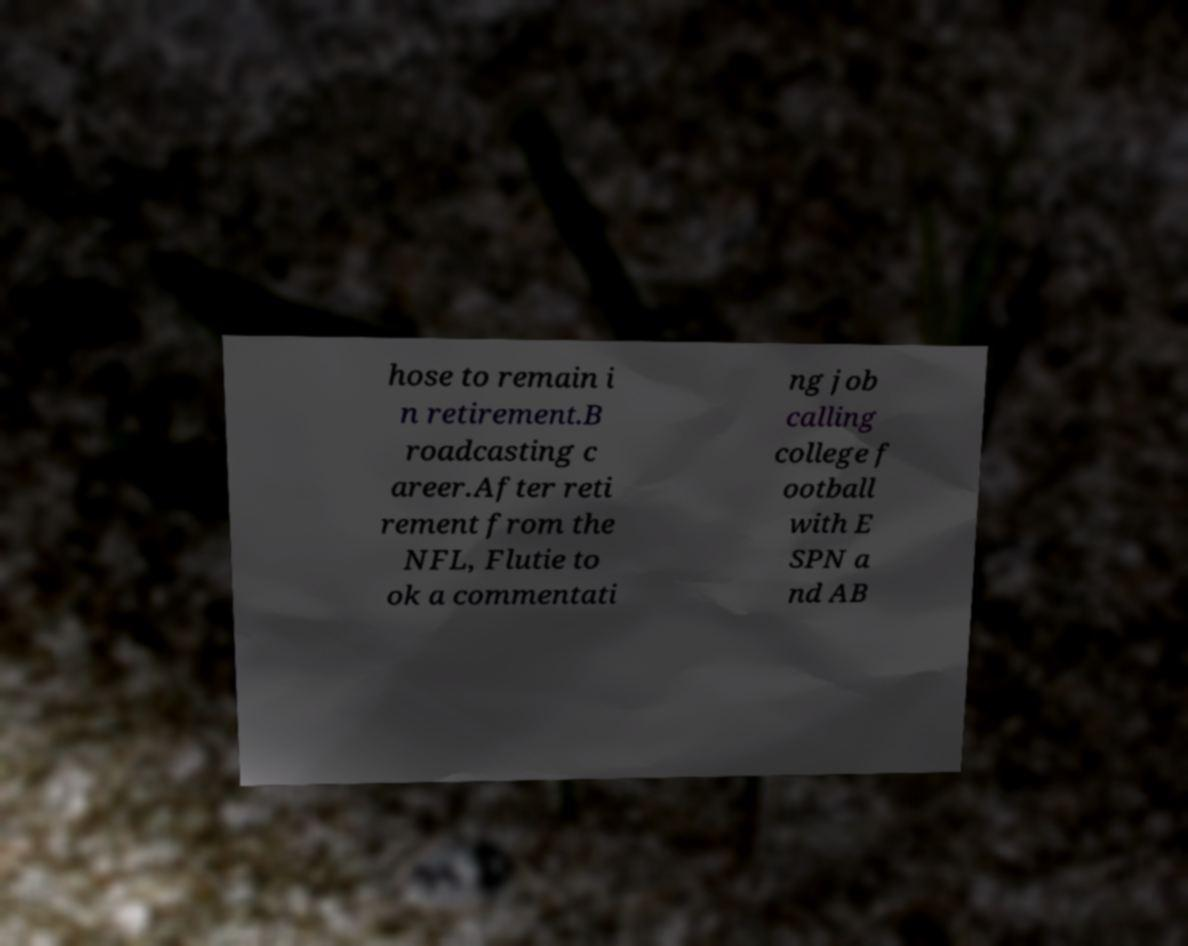There's text embedded in this image that I need extracted. Can you transcribe it verbatim? hose to remain i n retirement.B roadcasting c areer.After reti rement from the NFL, Flutie to ok a commentati ng job calling college f ootball with E SPN a nd AB 